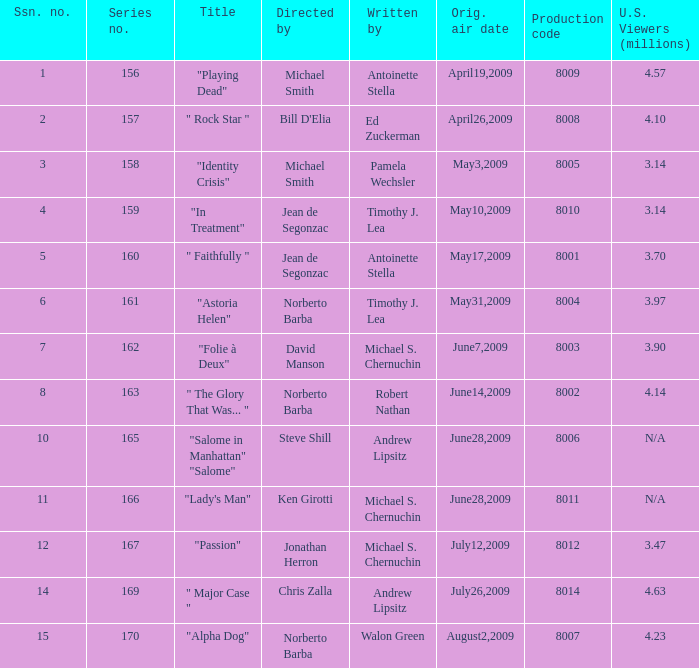Who are the writers when the production code is 8011? Michael S. Chernuchin. 